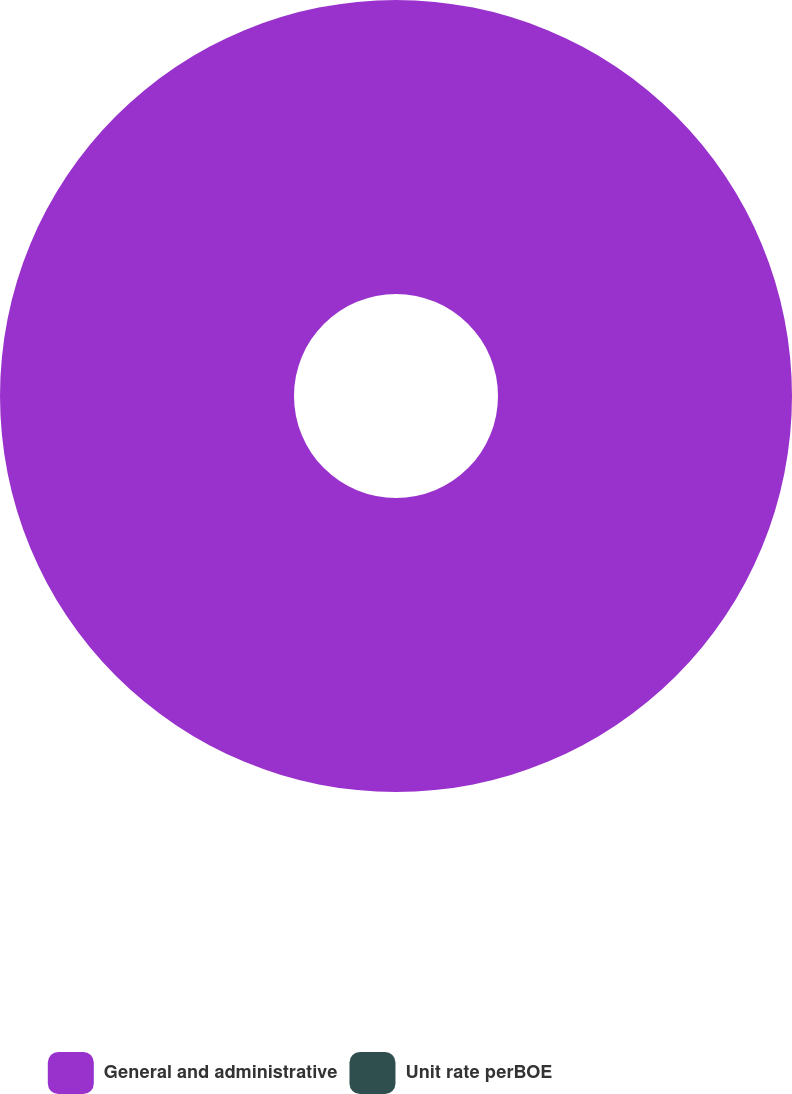Convert chart. <chart><loc_0><loc_0><loc_500><loc_500><pie_chart><fcel>General and administrative<fcel>Unit rate perBOE<nl><fcel>100.0%<fcel>0.0%<nl></chart> 